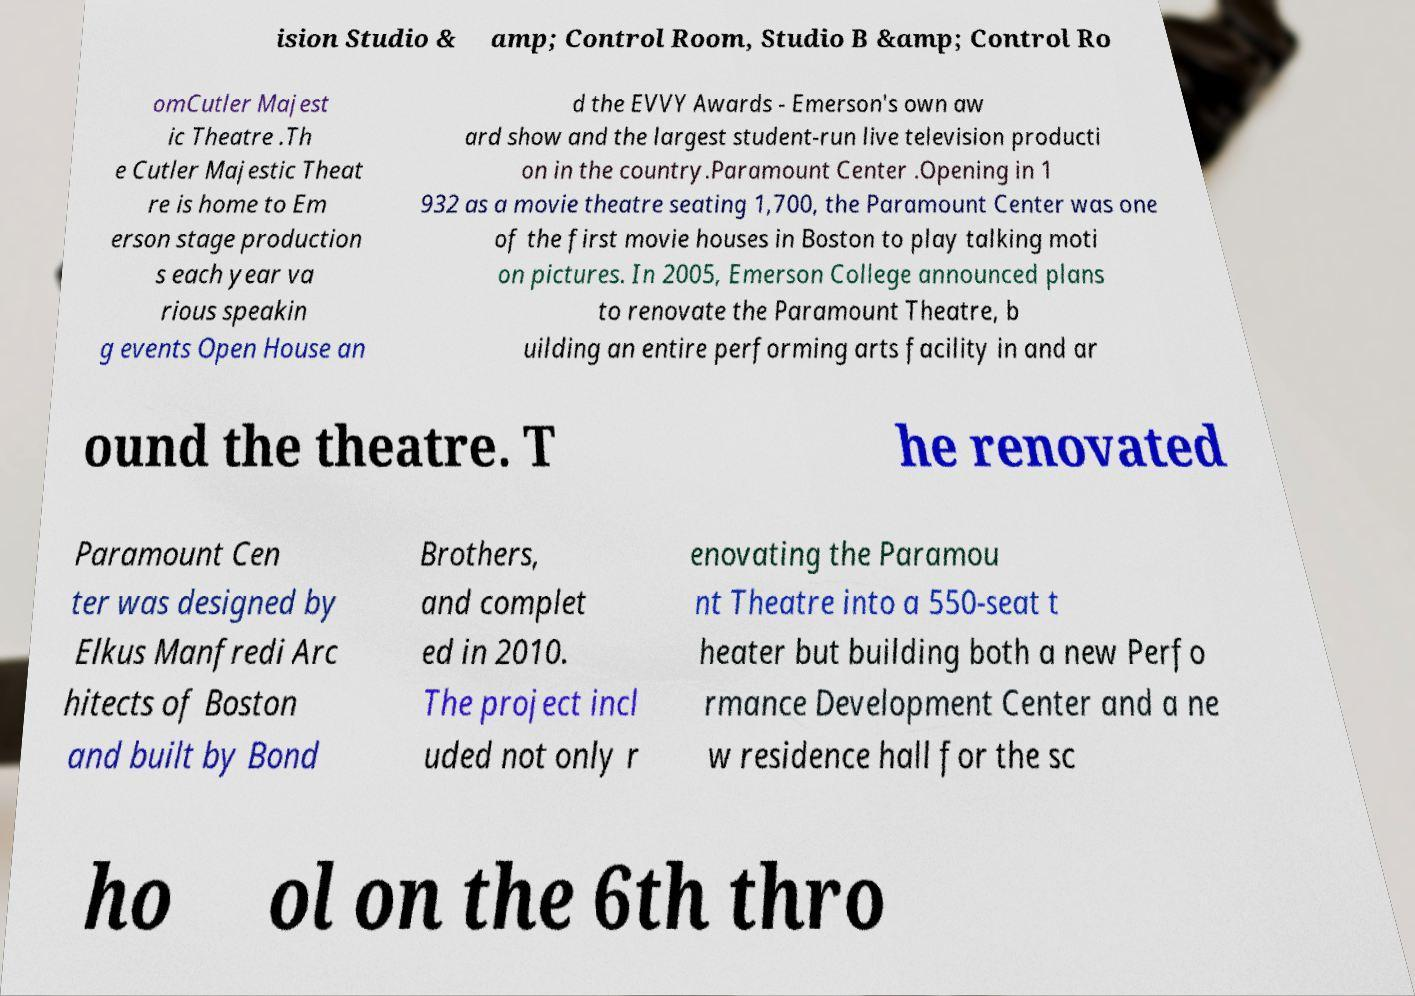What messages or text are displayed in this image? I need them in a readable, typed format. ision Studio & amp; Control Room, Studio B &amp; Control Ro omCutler Majest ic Theatre .Th e Cutler Majestic Theat re is home to Em erson stage production s each year va rious speakin g events Open House an d the EVVY Awards - Emerson's own aw ard show and the largest student-run live television producti on in the country.Paramount Center .Opening in 1 932 as a movie theatre seating 1,700, the Paramount Center was one of the first movie houses in Boston to play talking moti on pictures. In 2005, Emerson College announced plans to renovate the Paramount Theatre, b uilding an entire performing arts facility in and ar ound the theatre. T he renovated Paramount Cen ter was designed by Elkus Manfredi Arc hitects of Boston and built by Bond Brothers, and complet ed in 2010. The project incl uded not only r enovating the Paramou nt Theatre into a 550-seat t heater but building both a new Perfo rmance Development Center and a ne w residence hall for the sc ho ol on the 6th thro 